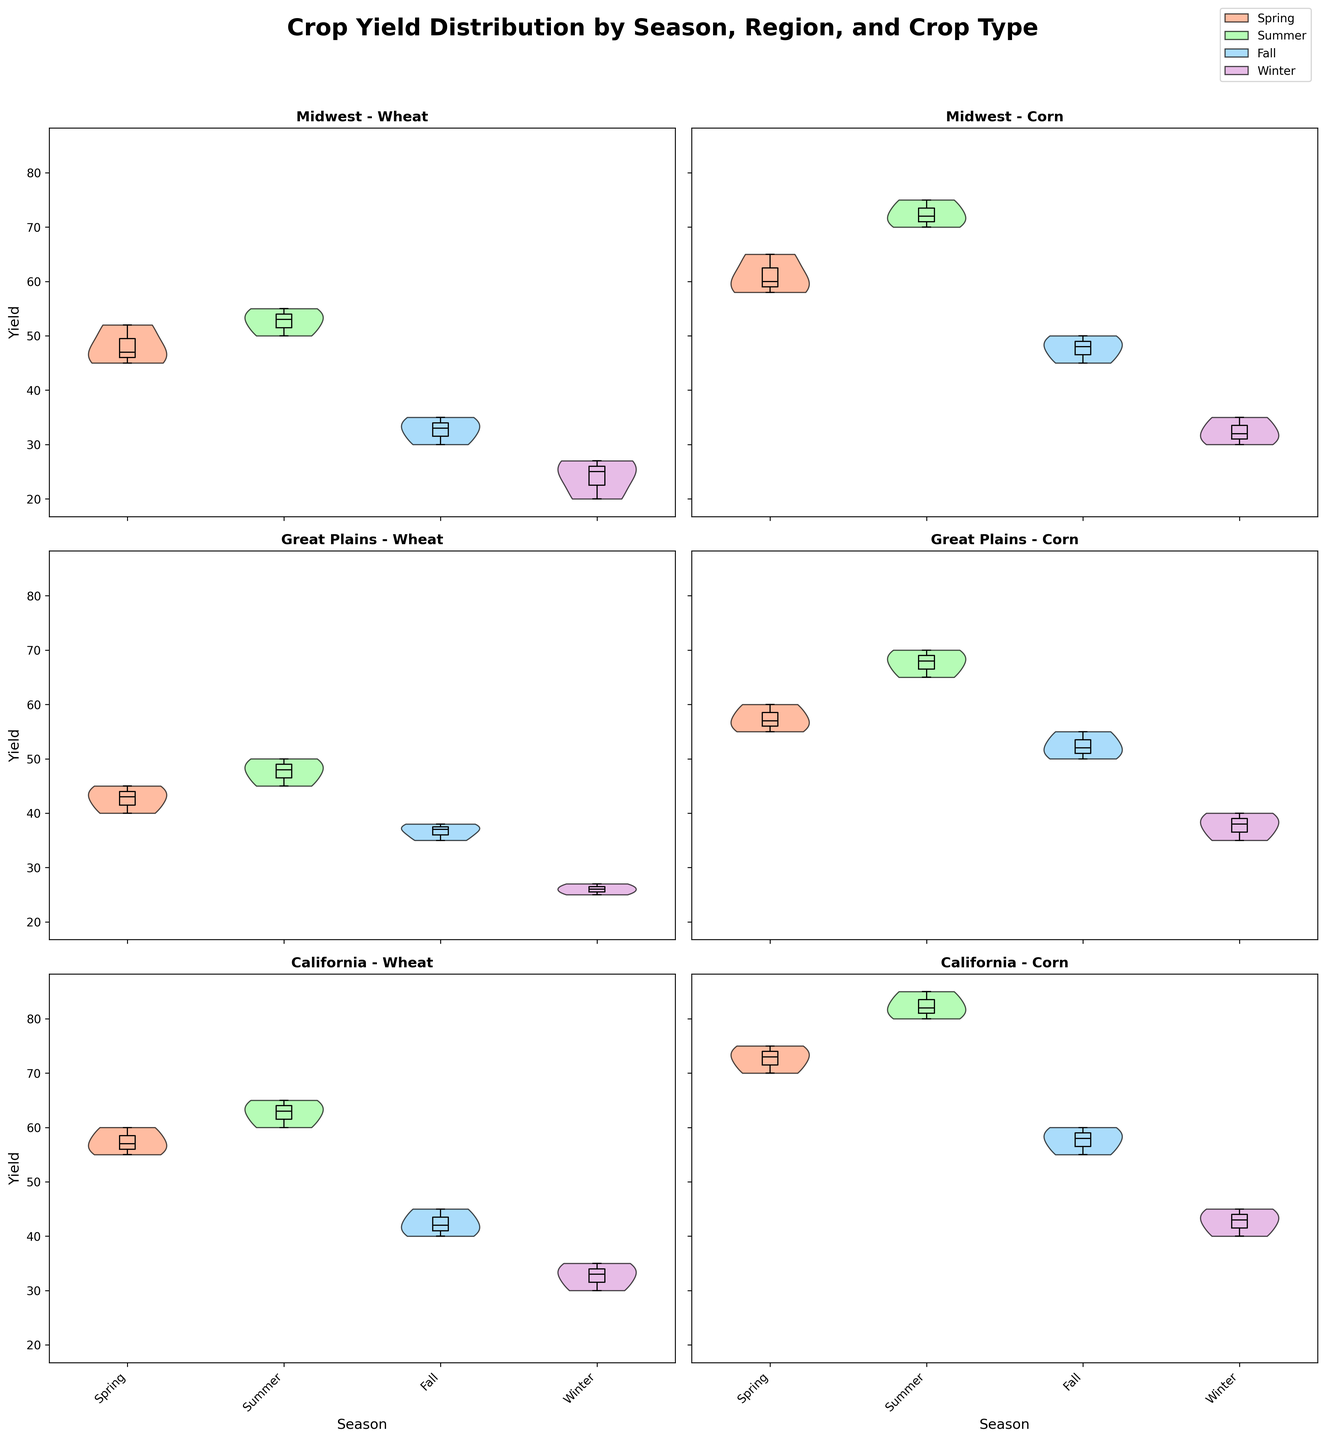What are the regions compared in the plot? The plot compares three regions: Midwest, Great Plains, and California. Each of these regions appears on the y-axis, and their yields are shown for both wheat and corn, across different seasons.
Answer: Midwest, Great Plains, California Which season shows the highest median yield for corn in California? The highest median yield for corn in California can be observed by looking at the box plot overlay on top of the violins for corn in California. The medians are the horizontal lines in the box plots. By comparing these lines across the seasons, the highest median yield is in the summer.
Answer: Summer How does the spread of wheat yields in the winter compare across different regions? To compare the spread, we examine the widths of the violin plots for wheat in the winter season across the different regions. In the chart, the Midwest and Great Plains show narrower violins, indicating less variability. California shows a wider violin, suggesting a higher variability in winter wheat yields.
Answer: California has the highest variability Which crop has a more consistent yield in the summer in the Great Plains? Consistency in yields can be observed by looking at the spread in the violin plots and box plots. For the Great Plains, the wheat's summer yield violin is narrower, suggesting more consistency compared to corn, which shows a wider spread.
Answer: Wheat What can be inferred about the yield variation of wheat in the Midwest during fall? The yield of wheat in the Midwest during fall can be observed from the violin plot. It is relatively narrow, indicating lower variation. Additionally, the box plot within confirms the consistency with a compact interquartile range.
Answer: Low variation What's the difference between the median yields of corn in the summer and winter in the Midwest? To find this, we look at the median lines in the box plots for corn yields in the summer and winter in the Midwest. Summer shows a median around 72, and winter shows a median around 32. The difference is calculated as 72 - 32.
Answer: 40 Which crop and season combination shows the lowest median yield in the Great Plains? The lowest median yield in the Great Plains can be determined by examining the medians of the box plots across all crop and season combinations. Winter wheat shows the lowest median yield.
Answer: Winter wheat How does the median yield of spring wheat in California compare to that in the Midwest? By checking the median lines in the box plots for spring wheat in both regions, we see that California has a higher median yield than the Midwest. California’s median is at 57, while the Midwest’s is at 47.
Answer: Higher in California What does the box plot reveal about the outliers in wheat yield in the winter across regions? Outliers are indicated by markers outside of the whiskers in the box plot. In the winter, the box plots for wheat across the Midwest, Great Plains, and California show outliers. Specifically, the Midwest has a few data points marked as outliers below 20.
Answer: Midwest has outliers below 20 